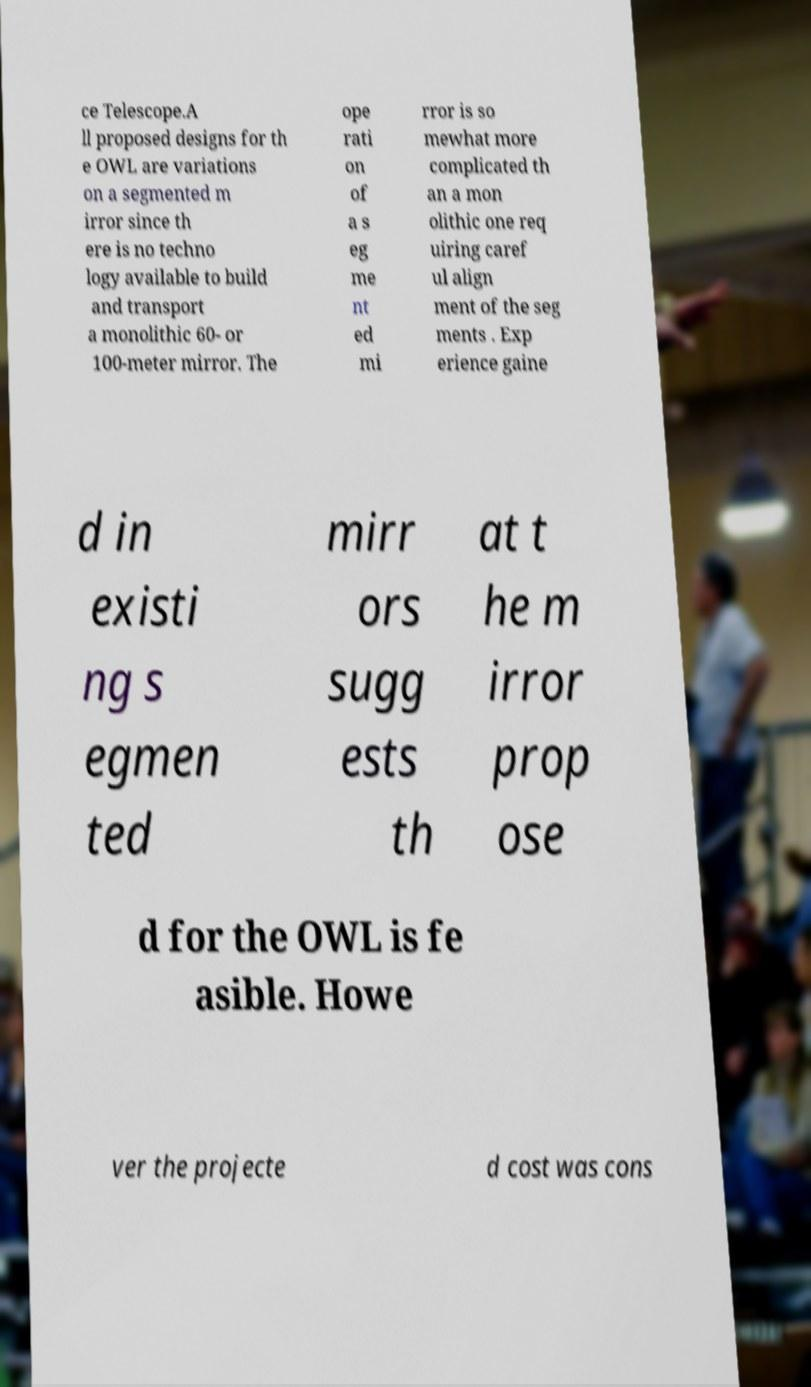Can you accurately transcribe the text from the provided image for me? ce Telescope.A ll proposed designs for th e OWL are variations on a segmented m irror since th ere is no techno logy available to build and transport a monolithic 60- or 100-meter mirror. The ope rati on of a s eg me nt ed mi rror is so mewhat more complicated th an a mon olithic one req uiring caref ul align ment of the seg ments . Exp erience gaine d in existi ng s egmen ted mirr ors sugg ests th at t he m irror prop ose d for the OWL is fe asible. Howe ver the projecte d cost was cons 